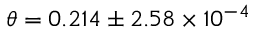<formula> <loc_0><loc_0><loc_500><loc_500>\theta = 0 . 2 1 4 \pm 2 . 5 8 \times 1 0 ^ { - 4 }</formula> 